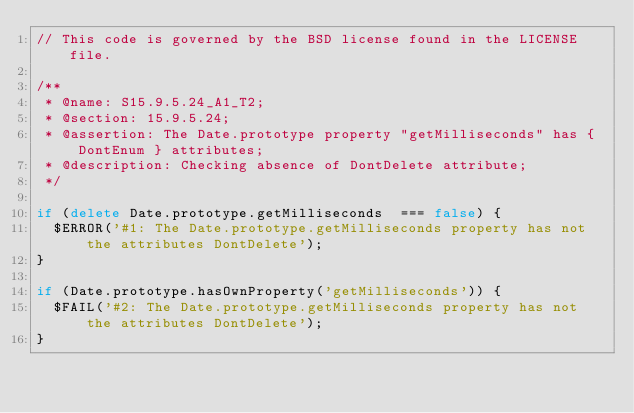<code> <loc_0><loc_0><loc_500><loc_500><_JavaScript_>// This code is governed by the BSD license found in the LICENSE file.

/**
 * @name: S15.9.5.24_A1_T2;
 * @section: 15.9.5.24;
 * @assertion: The Date.prototype property "getMilliseconds" has { DontEnum } attributes;
 * @description: Checking absence of DontDelete attribute;
 */

if (delete Date.prototype.getMilliseconds  === false) {
  $ERROR('#1: The Date.prototype.getMilliseconds property has not the attributes DontDelete');
}

if (Date.prototype.hasOwnProperty('getMilliseconds')) {
  $FAIL('#2: The Date.prototype.getMilliseconds property has not the attributes DontDelete');
}

</code> 